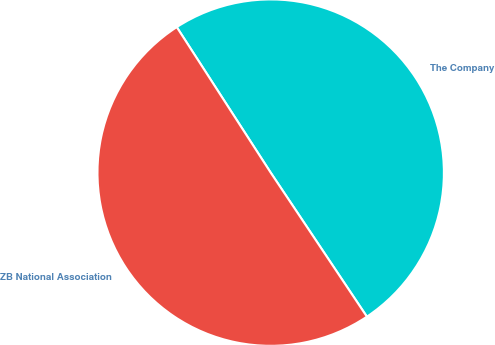<chart> <loc_0><loc_0><loc_500><loc_500><pie_chart><fcel>The Company<fcel>ZB National Association<nl><fcel>49.75%<fcel>50.25%<nl></chart> 